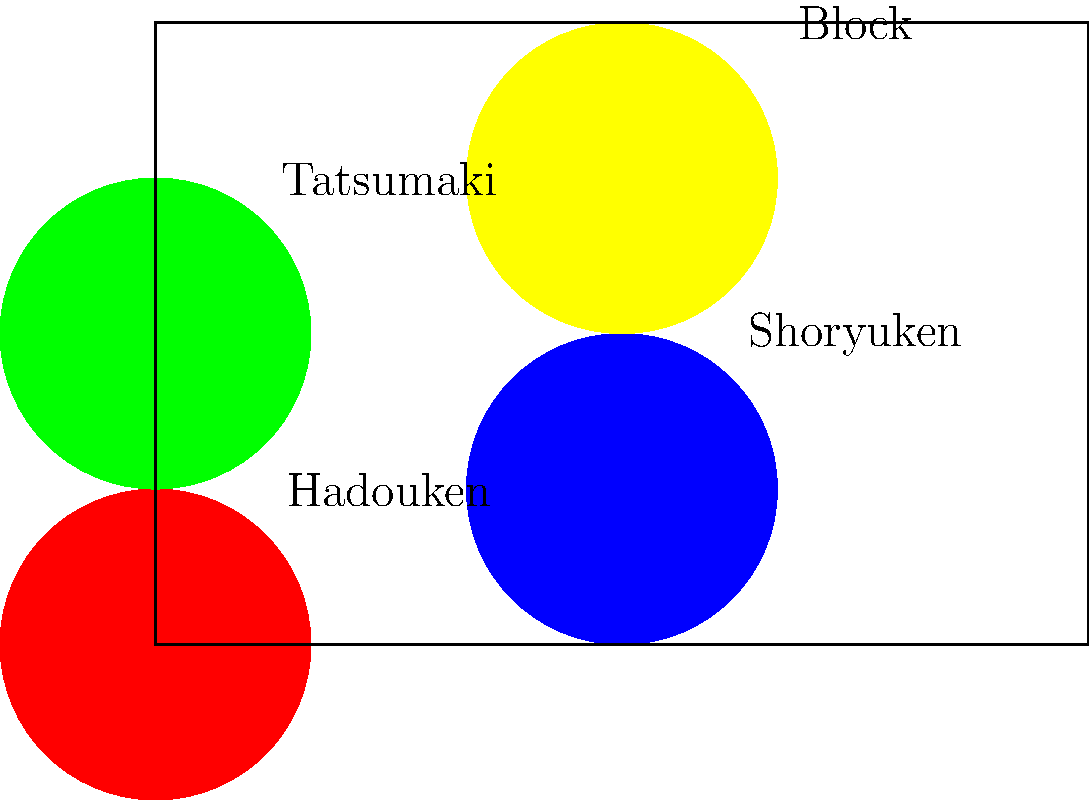In a classic Street Fighter match, which sequence of moves would be most effective for a defensive player transitioning into an offensive strategy? To determine the most effective sequence for a defensive player transitioning to offense, let's analyze each move:

1. Block: This is crucial for a defensive player to start with, as it protects against incoming attacks.

2. Tatsumaki (Hurricane Kick): Often used as a mix-up tool, it can help create space or close distance quickly after blocking.

3. Hadouken (Fireball): A projectile that can be used to control space and force the opponent to approach or jump.

4. Shoryuken (Dragon Punch): A powerful anti-air move that can punish opponents who try to jump in after the Hadouken.

The most effective sequence would be:

Block → Tatsumaki → Hadouken → Shoryuken

This sequence allows the player to:
1. Defend against initial attacks
2. Create space or close distance
3. Control the opponent's movement
4. Punish any aggressive responses

This progression smoothly transitions from a defensive stance to an offensive one, utilizing the strengths of each move in a logical order.
Answer: Block, Tatsumaki, Hadouken, Shoryuken 